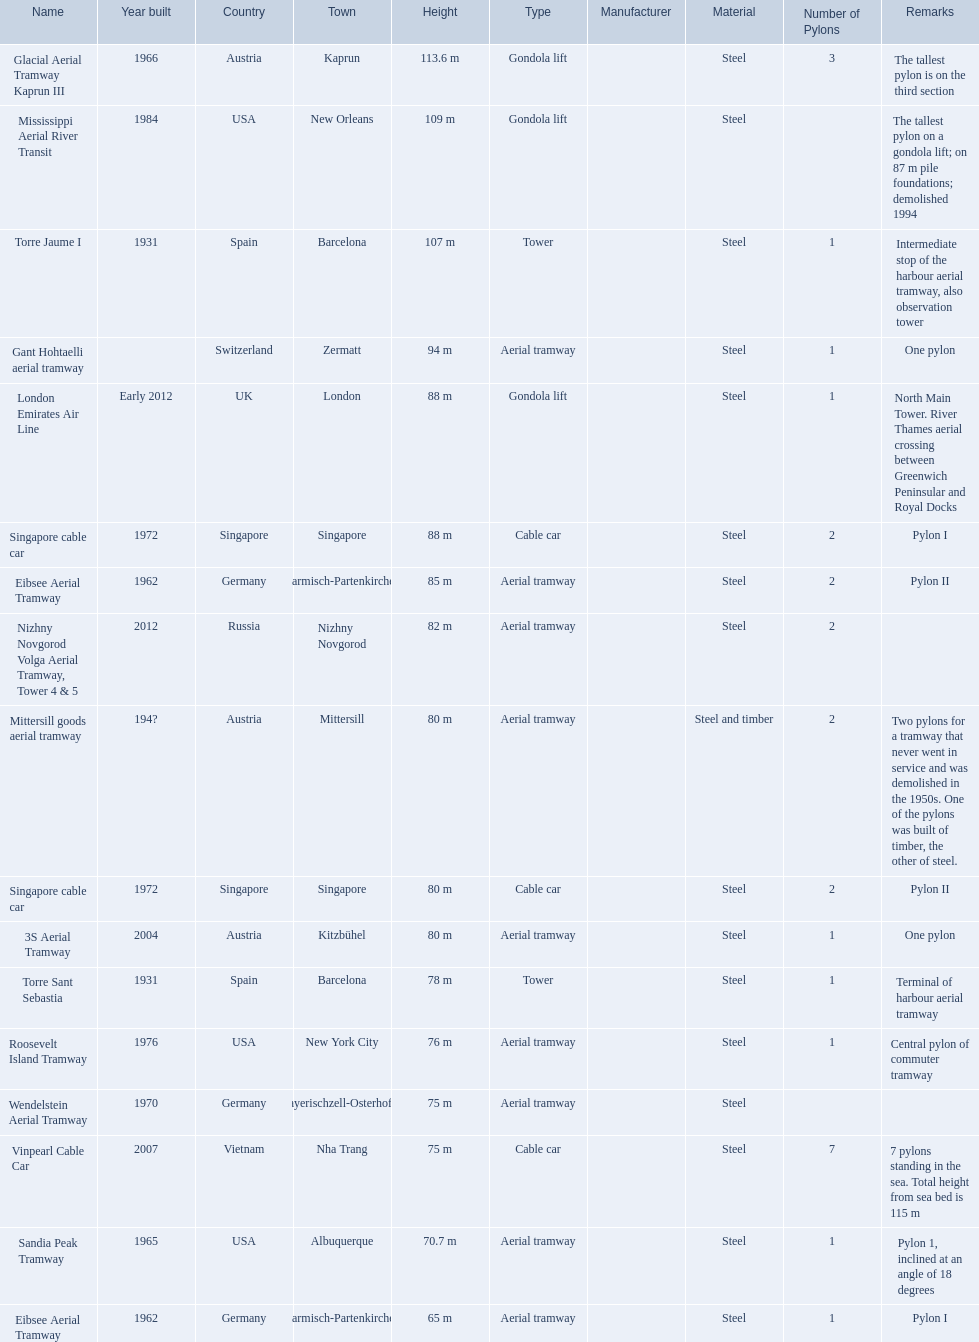Which lift has the second highest height? Mississippi Aerial River Transit. What is the value of the height? 109 m. 